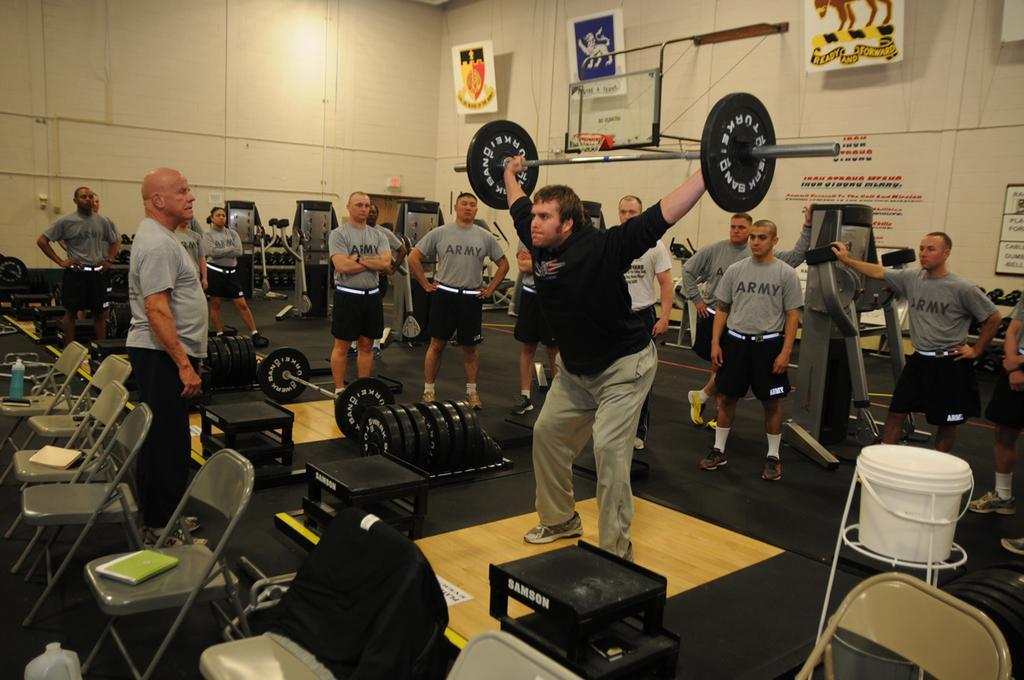Please provide a concise description of this image. In this picture we can see a man in the black hoodie is lifting a weightlifting bar. In front of the man there are chairs and on the right side of the man there is a white bucket on a stand. Behind the man there are some gym equipments, a group of people standing on the floor and a wall with the boards and some objects. 